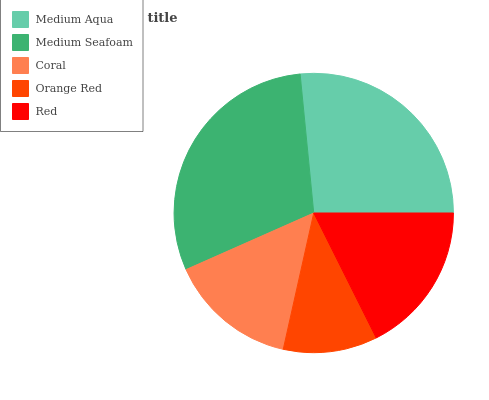Is Orange Red the minimum?
Answer yes or no. Yes. Is Medium Seafoam the maximum?
Answer yes or no. Yes. Is Coral the minimum?
Answer yes or no. No. Is Coral the maximum?
Answer yes or no. No. Is Medium Seafoam greater than Coral?
Answer yes or no. Yes. Is Coral less than Medium Seafoam?
Answer yes or no. Yes. Is Coral greater than Medium Seafoam?
Answer yes or no. No. Is Medium Seafoam less than Coral?
Answer yes or no. No. Is Red the high median?
Answer yes or no. Yes. Is Red the low median?
Answer yes or no. Yes. Is Coral the high median?
Answer yes or no. No. Is Medium Aqua the low median?
Answer yes or no. No. 